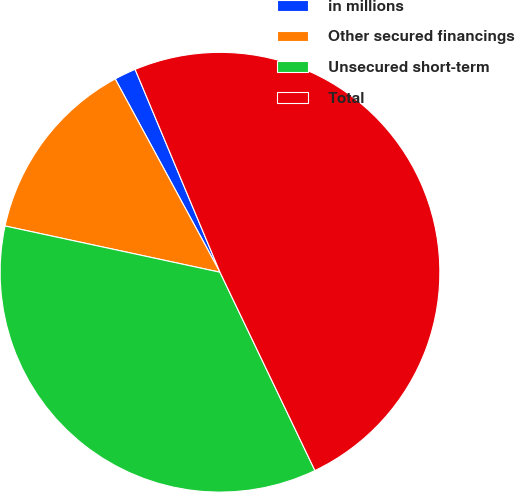<chart> <loc_0><loc_0><loc_500><loc_500><pie_chart><fcel>in millions<fcel>Other secured financings<fcel>Unsecured short-term<fcel>Total<nl><fcel>1.6%<fcel>13.72%<fcel>35.48%<fcel>49.2%<nl></chart> 